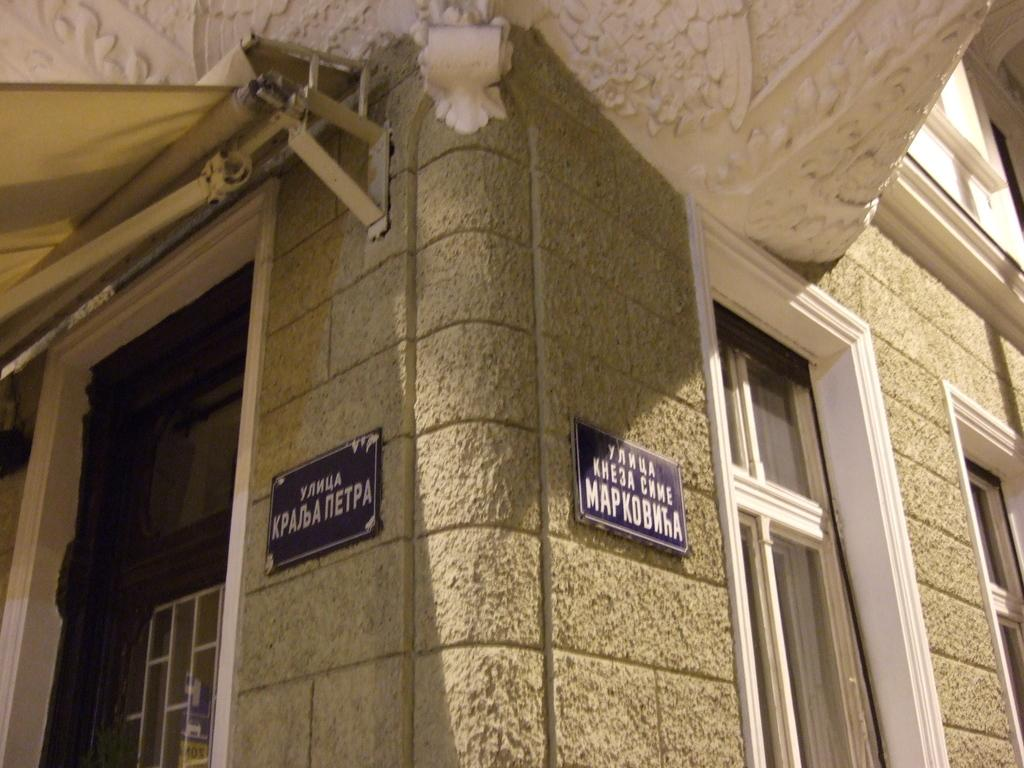What type of structures can be seen in the image? There are boards and windows in the image. What type of building might these structures be part of? The boards and windows are part of a building. What type of tin can be seen on the face of the building in the image? There is no tin visible on the face of the building in the image. What type of metal is used to construct the windows in the image? The provided facts do not specify the type of metal used to construct the windows in the image. 